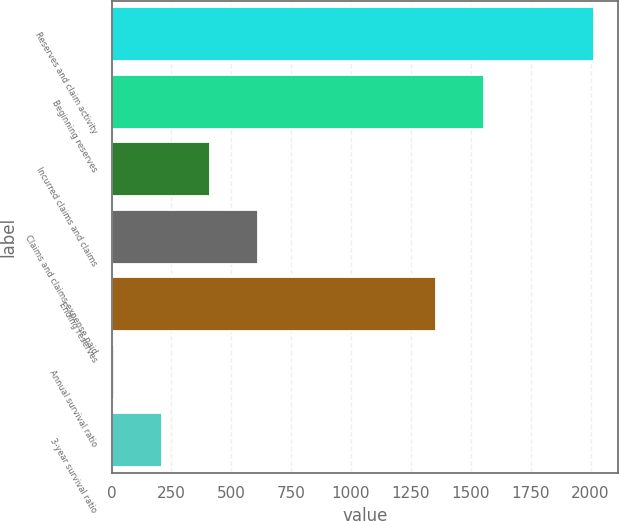Convert chart to OTSL. <chart><loc_0><loc_0><loc_500><loc_500><bar_chart><fcel>Reserves and claim activity<fcel>Beginning reserves<fcel>Incurred claims and claims<fcel>Claims and claims expense paid<fcel>Ending reserves<fcel>Annual survival ratio<fcel>3-year survival ratio<nl><fcel>2016<fcel>1556.74<fcel>410.08<fcel>610.82<fcel>1356<fcel>8.6<fcel>209.34<nl></chart> 